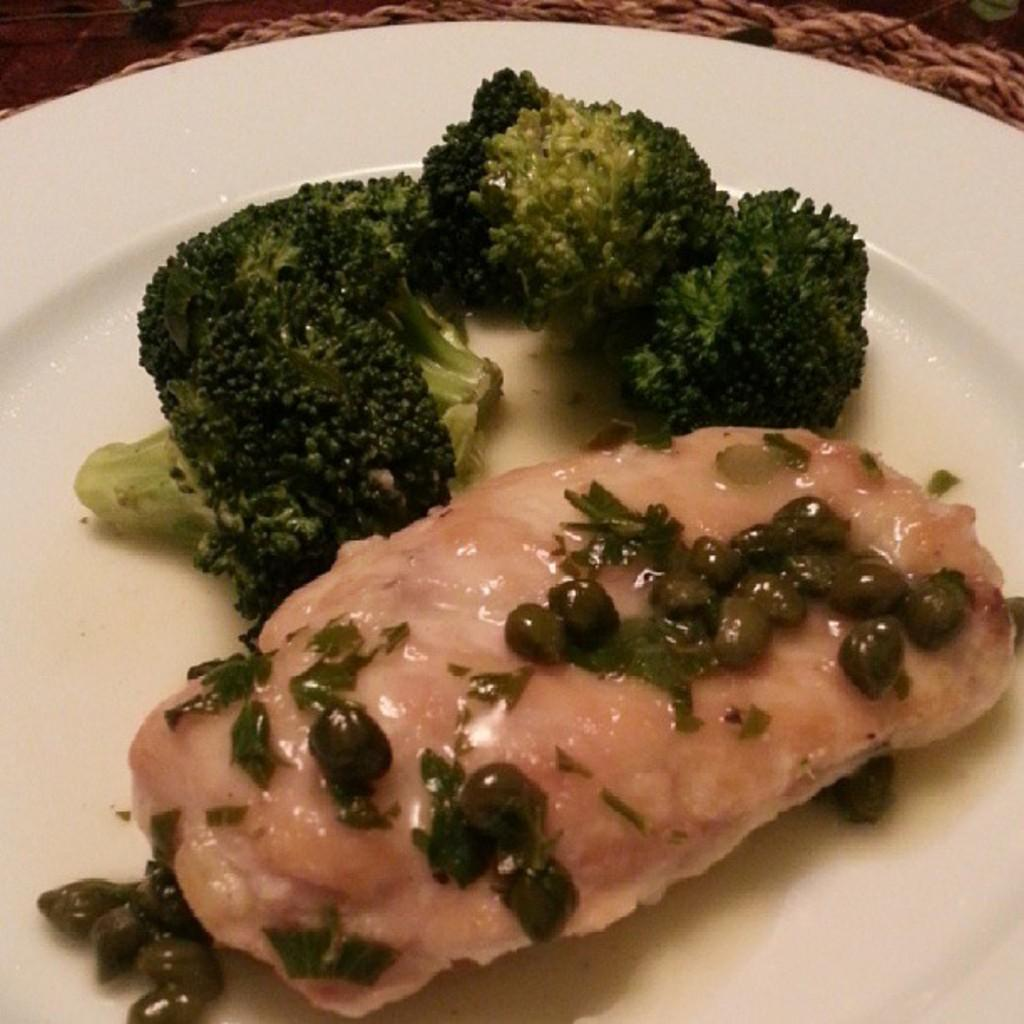What type of vegetable can be seen in the image? There is broccoli in the image. What other type of food is present in the image? There are beans in the image. How is the food arranged in the image? The food is on a white plate in the image. What type of circle can be seen in the image? There is no circle present in the image. What type of learning is taking place in the image? The image does not depict any learning activity. 